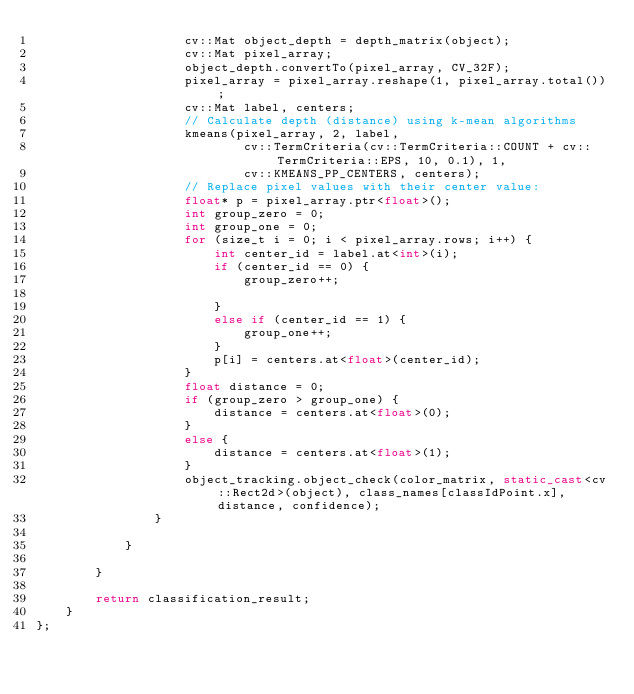<code> <loc_0><loc_0><loc_500><loc_500><_C++_>					cv::Mat object_depth = depth_matrix(object);
					cv::Mat pixel_array;
					object_depth.convertTo(pixel_array, CV_32F);
					pixel_array = pixel_array.reshape(1, pixel_array.total());
					cv::Mat label, centers;
					// Calculate depth (distance) using k-mean algorithms
					kmeans(pixel_array, 2, label,
							cv::TermCriteria(cv::TermCriteria::COUNT + cv::TermCriteria::EPS, 10, 0.1), 1,
							cv::KMEANS_PP_CENTERS, centers);
					// Replace pixel values with their center value:
					float* p = pixel_array.ptr<float>();
					int group_zero = 0;
					int group_one = 0;
					for (size_t i = 0; i < pixel_array.rows; i++) {
						int center_id = label.at<int>(i);
						if (center_id == 0) {
							group_zero++;

						}
						else if (center_id == 1) {
							group_one++;
						}
						p[i] = centers.at<float>(center_id);
					}
					float distance = 0;
					if (group_zero > group_one) {
						distance = centers.at<float>(0);
					}
					else {
						distance = centers.at<float>(1);
					}
					object_tracking.object_check(color_matrix, static_cast<cv::Rect2d>(object), class_names[classIdPoint.x], distance, confidence);
	            }

	        }
	        
	    }

		return classification_result;
	}
};
</code> 